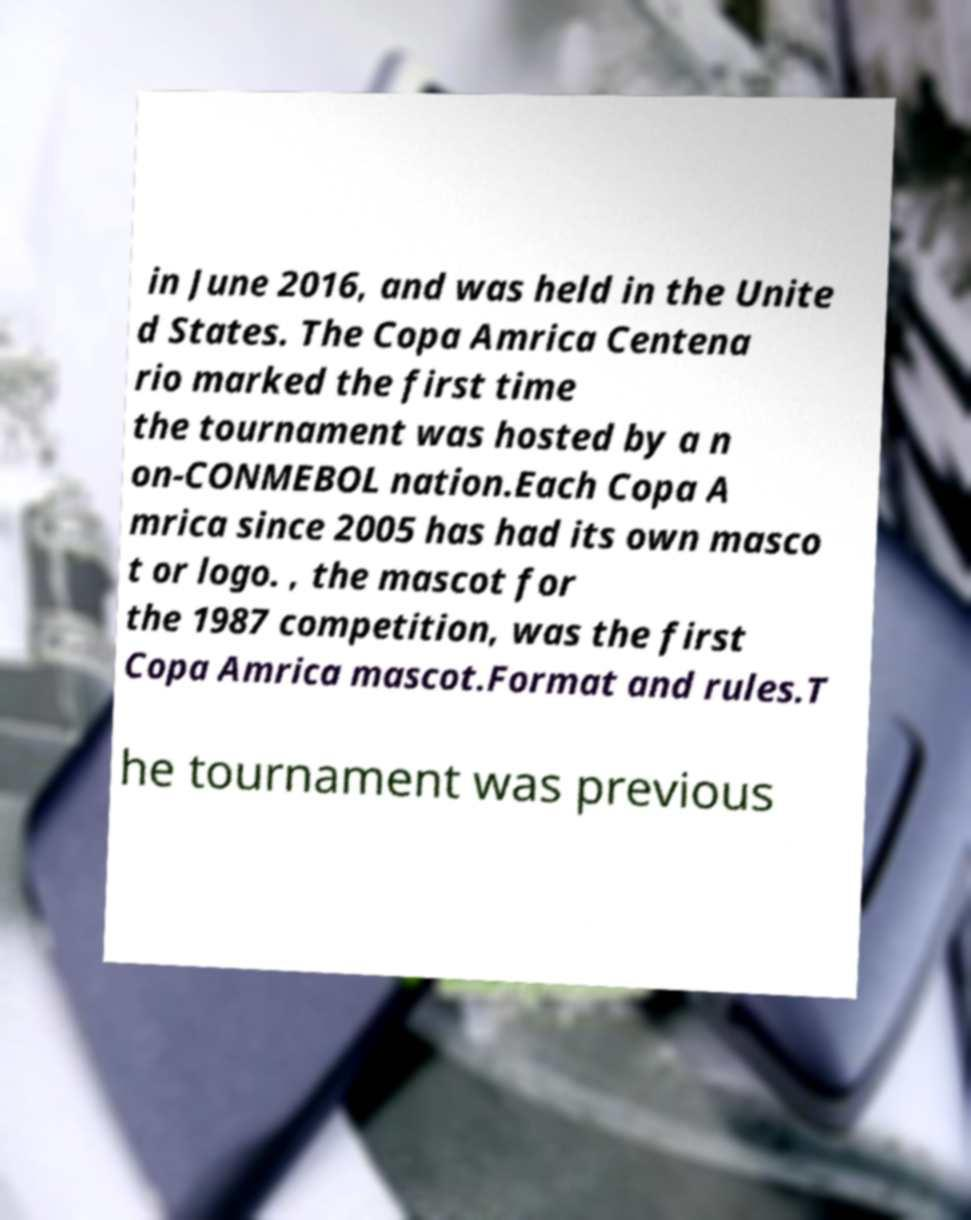There's text embedded in this image that I need extracted. Can you transcribe it verbatim? in June 2016, and was held in the Unite d States. The Copa Amrica Centena rio marked the first time the tournament was hosted by a n on-CONMEBOL nation.Each Copa A mrica since 2005 has had its own masco t or logo. , the mascot for the 1987 competition, was the first Copa Amrica mascot.Format and rules.T he tournament was previous 